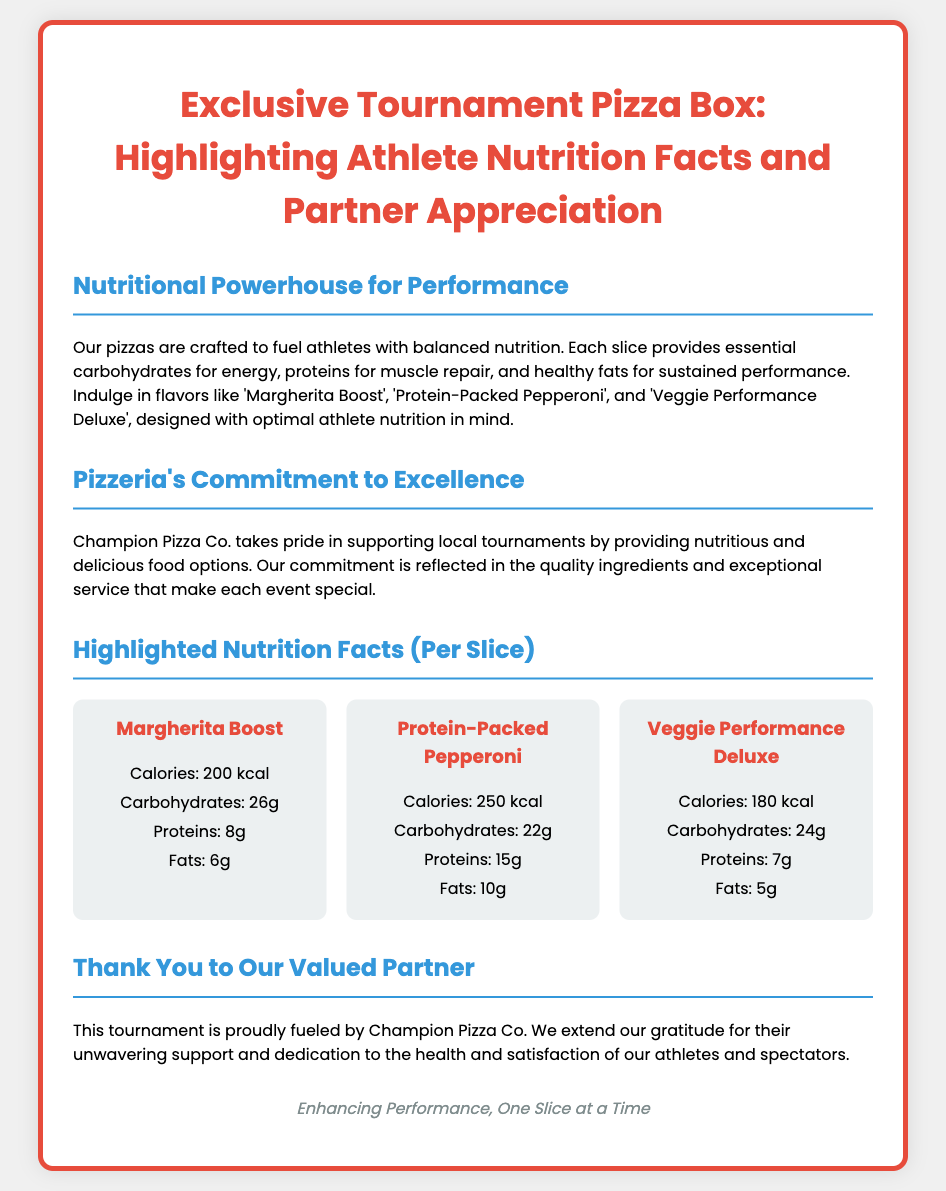What are the flavors highlighted in the Exclusive Tournament Pizza Box? The flavors mentioned are 'Margherita Boost', 'Protein-Packed Pepperoni', and 'Veggie Performance Deluxe'.
Answer: Margherita Boost, Protein-Packed Pepperoni, Veggie Performance Deluxe What is the calorie count for Veggie Performance Deluxe? The calorie count for Veggie Performance Deluxe is specified in the nutrition facts section.
Answer: 180 kcal What is the protein content in Protein-Packed Pepperoni? The protein content for Protein-Packed Pepperoni is mentioned in the nutrition facts section of the document.
Answer: 15g Who provides the food options for the tournament? The document specifically states that Champion Pizza Co. is providing the food options for the tournament.
Answer: Champion Pizza Co What is the main purpose of the pizzas as stated in the document? The document details that the pizzas are crafted to fuel athletes with balanced nutrition for optimal performance.
Answer: Fuel athletes with balanced nutrition What key ingredient types are highlighted for athlete nutrition? The document refers to essential carbohydrates, proteins, and healthy fats as key ingredients for athlete nutrition.
Answer: Carbohydrates, proteins, healthy fats How does Champion Pizza Co. show its commitment to local tournaments? The document mentions that Champion Pizza Co. supports local tournaments by providing nutritious and delicious food options.
Answer: Providing nutritious and delicious food options What is the tagline mentioned at the bottom of the document? The footer contains a tagline that reinforces the pizzeria's mission related to performance.
Answer: Enhancing Performance, One Slice at a Time 